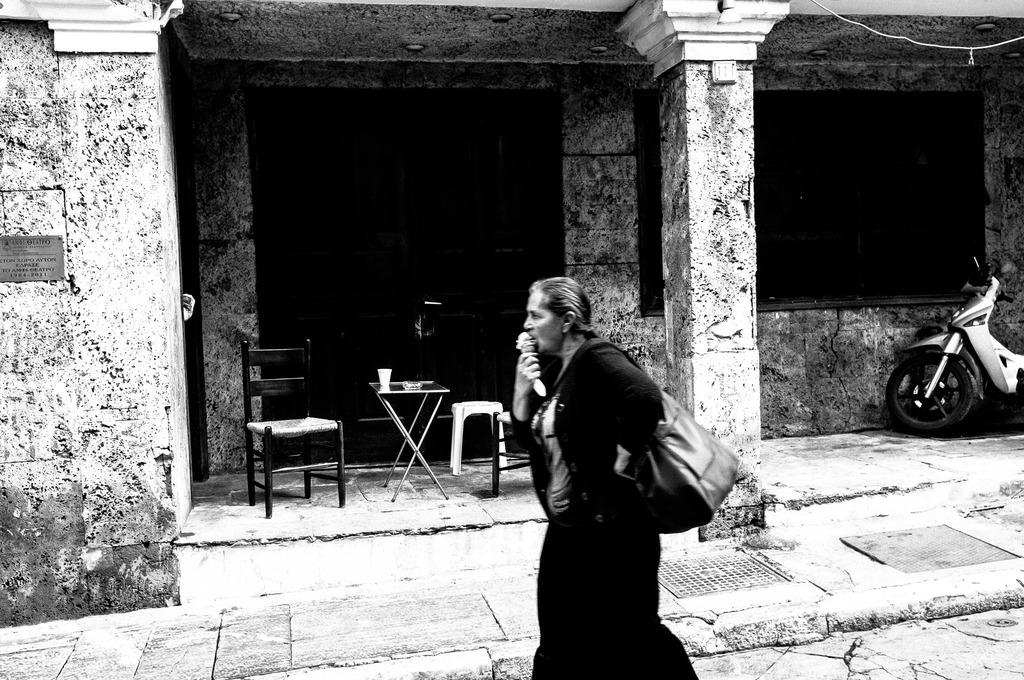Who is present in the image? There is a woman in the image. What is the woman carrying? The woman is carrying a handbag. What is the woman doing in the image? The woman is eating an ice cream. What can be seen in the background of the image? There is a table and a chair in the background of the image. What type of horn can be heard in the image? There is no horn present in the image, and therefore no sound can be heard. 